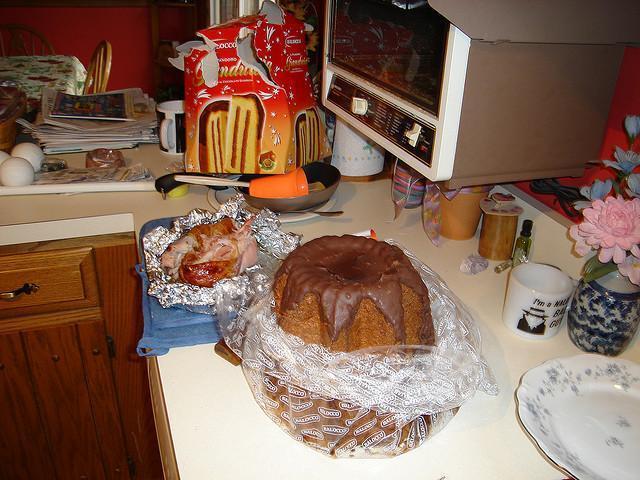How many chairs are visible?
Give a very brief answer. 0. How many eggs are on the counter?
Give a very brief answer. 3. How many towels are in this photo?
Give a very brief answer. 1. How many microwaves are there?
Give a very brief answer. 1. 